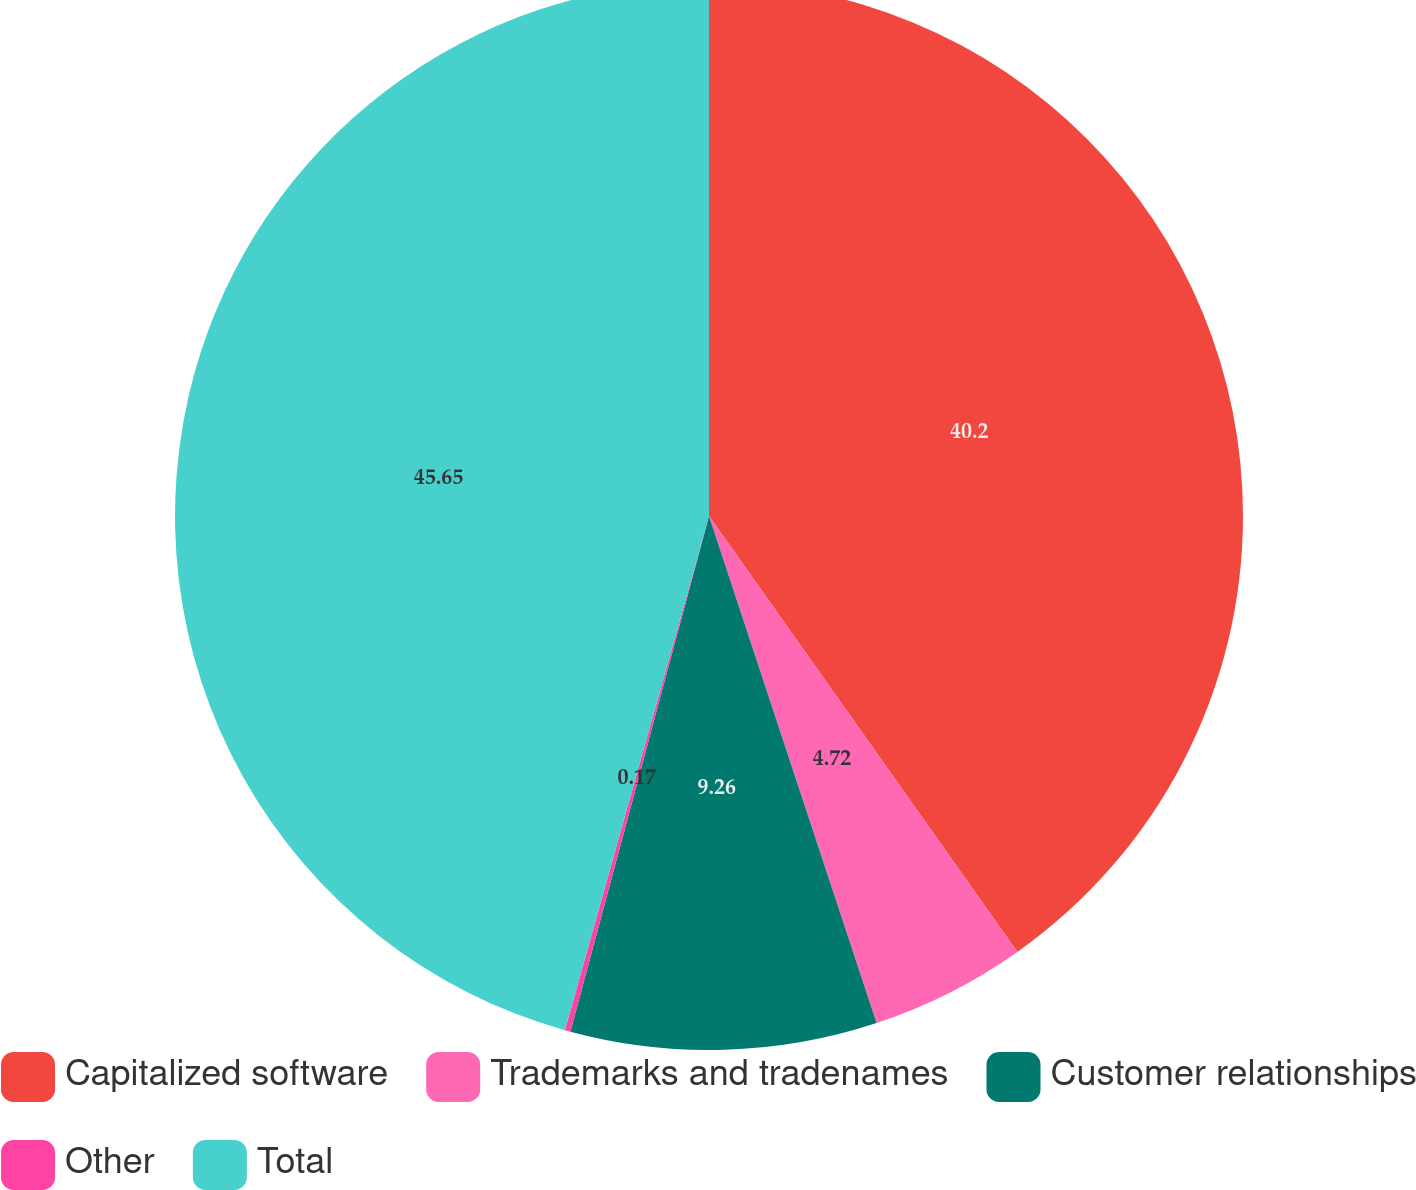<chart> <loc_0><loc_0><loc_500><loc_500><pie_chart><fcel>Capitalized software<fcel>Trademarks and tradenames<fcel>Customer relationships<fcel>Other<fcel>Total<nl><fcel>40.2%<fcel>4.72%<fcel>9.26%<fcel>0.17%<fcel>45.65%<nl></chart> 